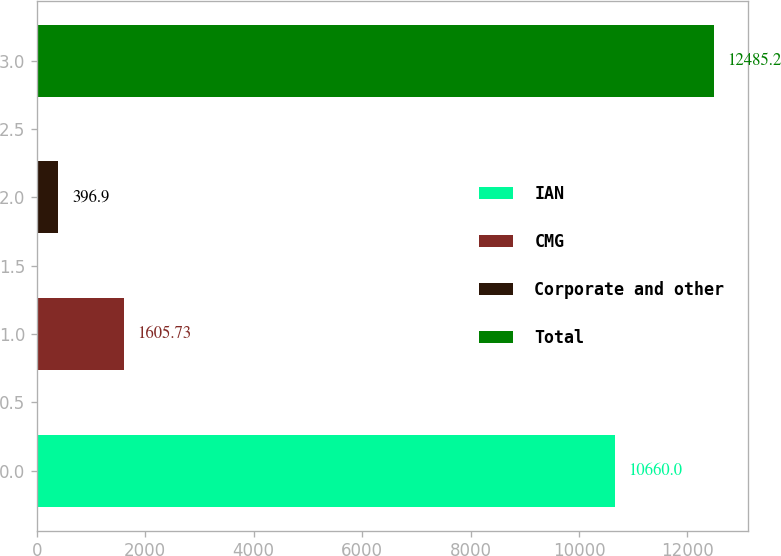Convert chart to OTSL. <chart><loc_0><loc_0><loc_500><loc_500><bar_chart><fcel>IAN<fcel>CMG<fcel>Corporate and other<fcel>Total<nl><fcel>10660<fcel>1605.73<fcel>396.9<fcel>12485.2<nl></chart> 